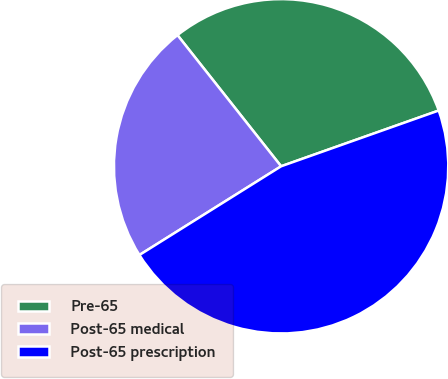Convert chart to OTSL. <chart><loc_0><loc_0><loc_500><loc_500><pie_chart><fcel>Pre-65<fcel>Post-65 medical<fcel>Post-65 prescription<nl><fcel>30.23%<fcel>23.26%<fcel>46.51%<nl></chart> 